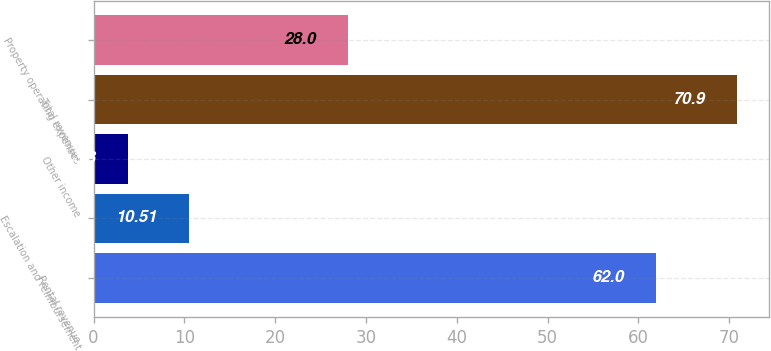<chart> <loc_0><loc_0><loc_500><loc_500><bar_chart><fcel>Rental revenue<fcel>Escalation and reimbursement<fcel>Other income<fcel>Total revenues<fcel>Property operating expenses<nl><fcel>62<fcel>10.51<fcel>3.8<fcel>70.9<fcel>28<nl></chart> 